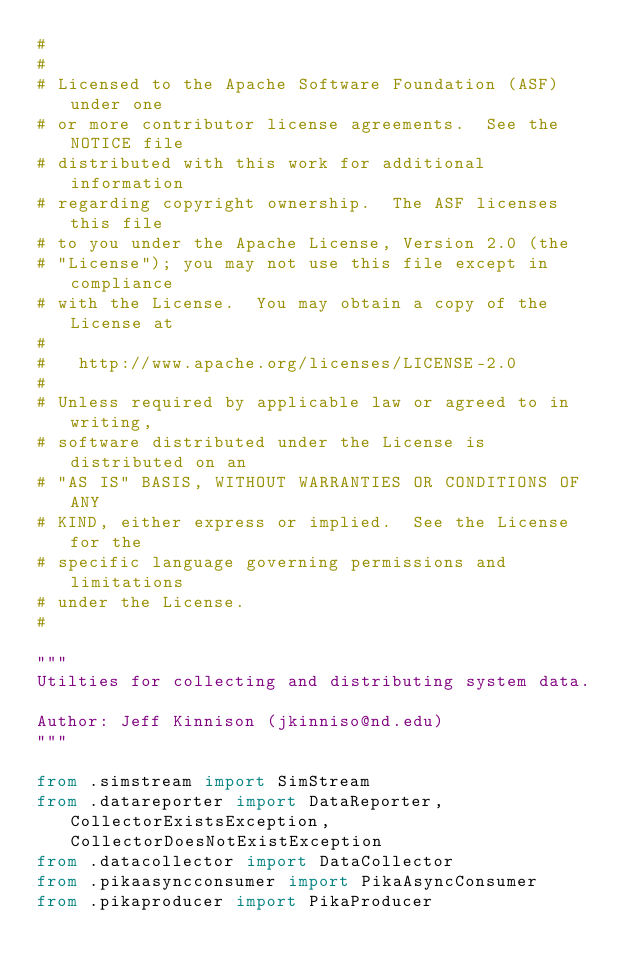<code> <loc_0><loc_0><loc_500><loc_500><_Python_>#
#
# Licensed to the Apache Software Foundation (ASF) under one
# or more contributor license agreements.  See the NOTICE file
# distributed with this work for additional information
# regarding copyright ownership.  The ASF licenses this file
# to you under the Apache License, Version 2.0 (the
# "License"); you may not use this file except in compliance
# with the License.  You may obtain a copy of the License at
#
#   http://www.apache.org/licenses/LICENSE-2.0
#
# Unless required by applicable law or agreed to in writing,
# software distributed under the License is distributed on an
# "AS IS" BASIS, WITHOUT WARRANTIES OR CONDITIONS OF ANY
# KIND, either express or implied.  See the License for the
# specific language governing permissions and limitations
# under the License.
#

"""
Utilties for collecting and distributing system data.

Author: Jeff Kinnison (jkinniso@nd.edu)
"""

from .simstream import SimStream
from .datareporter import DataReporter, CollectorExistsException, CollectorDoesNotExistException
from .datacollector import DataCollector
from .pikaasyncconsumer import PikaAsyncConsumer
from .pikaproducer import PikaProducer
</code> 